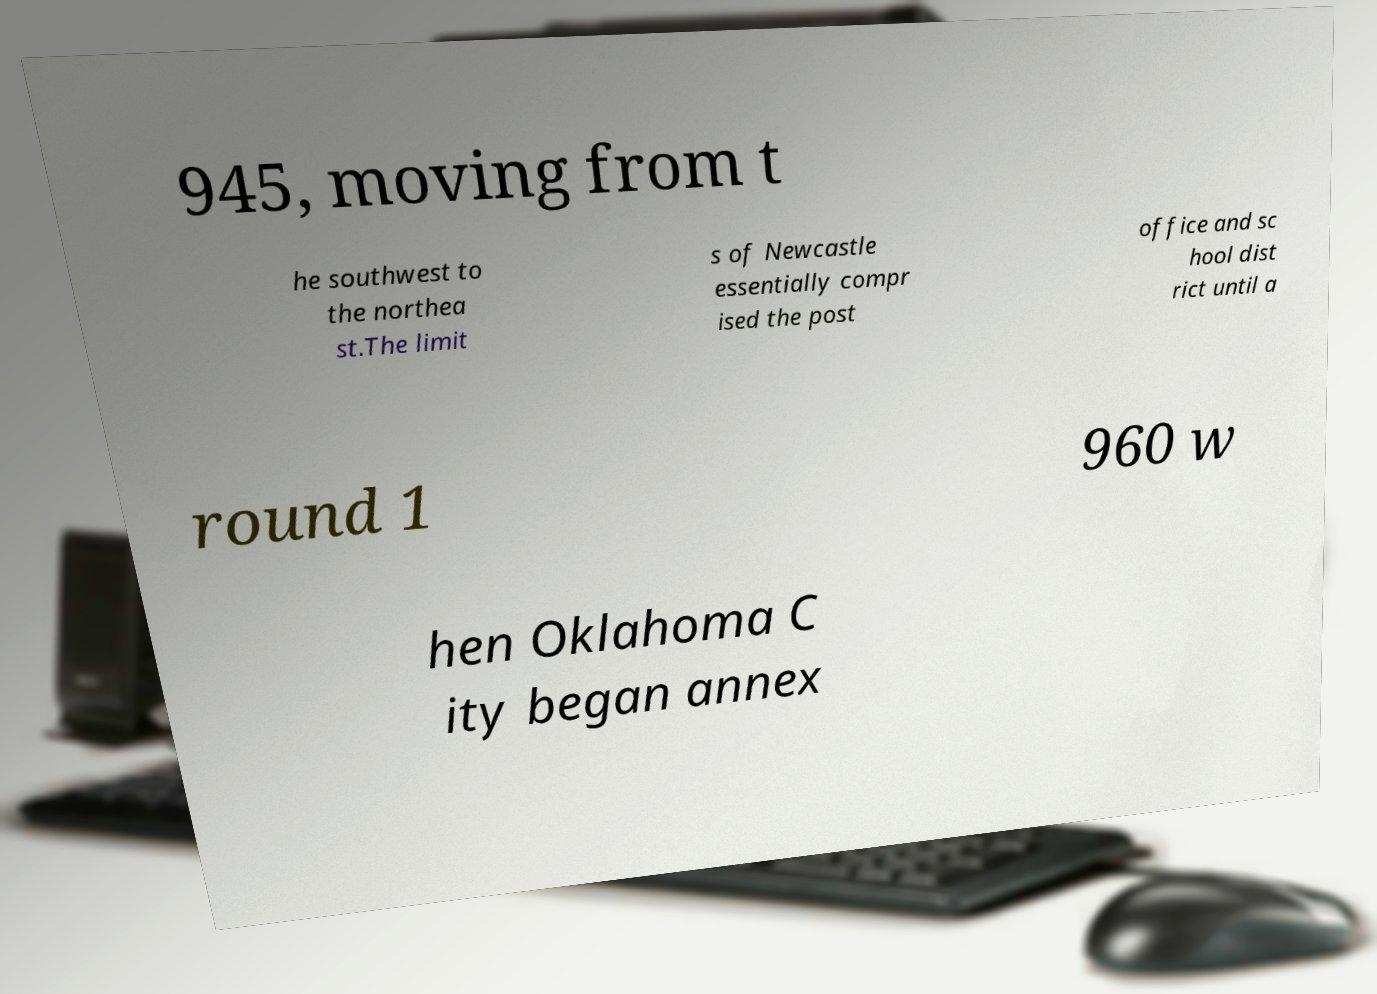Can you accurately transcribe the text from the provided image for me? 945, moving from t he southwest to the northea st.The limit s of Newcastle essentially compr ised the post office and sc hool dist rict until a round 1 960 w hen Oklahoma C ity began annex 